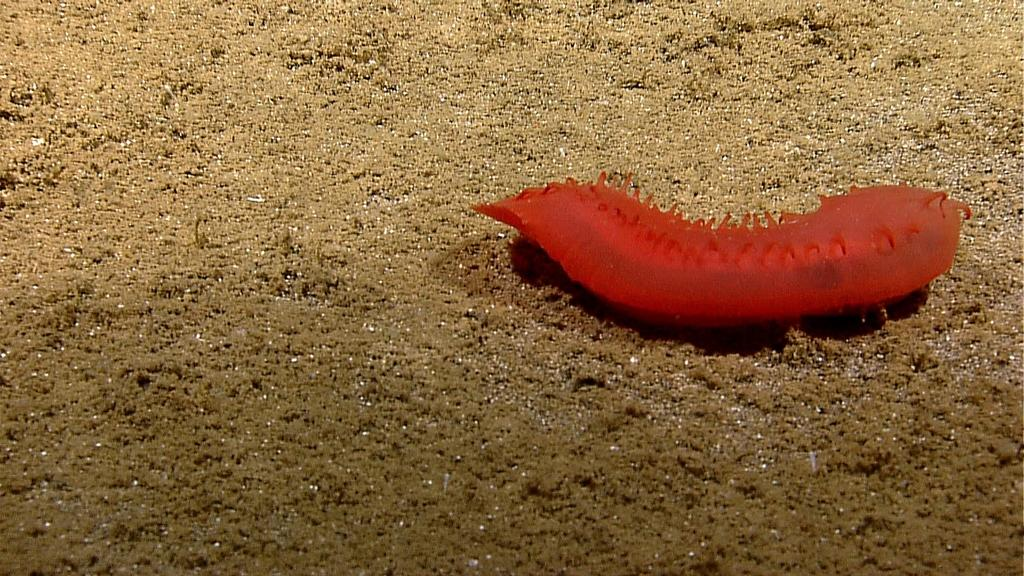What type of creature can be seen in the image? There is an insect in the image. What is the color of the insect? The insect is orange in color. Where is the insect located in the image? The insect is on the ground. What type of rhythm does the insect play in the image? There is no indication in the image that the insect is playing any rhythm, as insects do not have the ability to play music. 